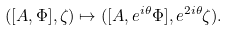Convert formula to latex. <formula><loc_0><loc_0><loc_500><loc_500>( [ A , \Phi ] , \zeta ) \mapsto ( [ A , e ^ { i \theta } \Phi ] , e ^ { 2 i \theta } \zeta ) .</formula> 